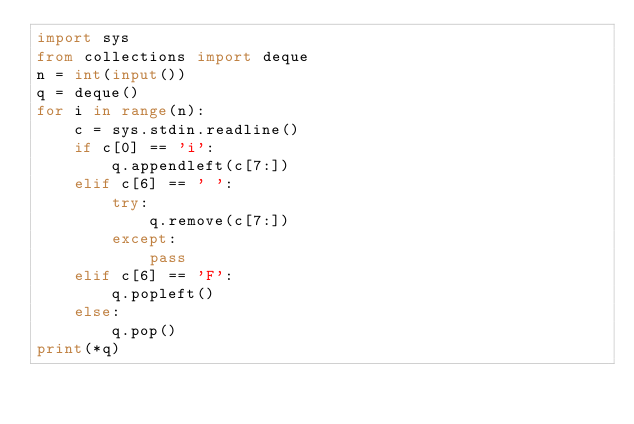<code> <loc_0><loc_0><loc_500><loc_500><_Python_>import sys
from collections import deque
n = int(input())
q = deque()
for i in range(n):
    c = sys.stdin.readline()
    if c[0] == 'i':
        q.appendleft(c[7:])
    elif c[6] == ' ':
        try:
            q.remove(c[7:])
        except:
            pass
    elif c[6] == 'F':
        q.popleft()
    else:
        q.pop()
print(*q)</code> 